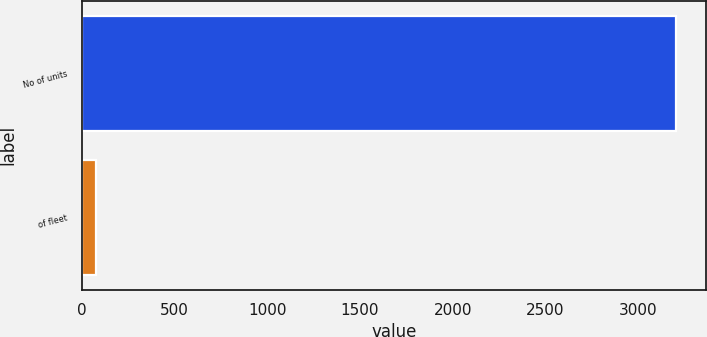<chart> <loc_0><loc_0><loc_500><loc_500><bar_chart><fcel>No of units<fcel>of fleet<nl><fcel>3206<fcel>75<nl></chart> 